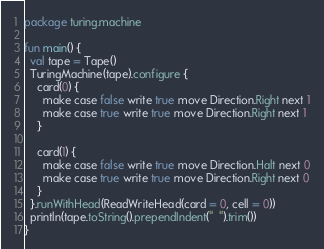<code> <loc_0><loc_0><loc_500><loc_500><_Kotlin_>package turing.machine

fun main() {
  val tape = Tape()
  TuringMachine(tape).configure {
    card(0) {
      make case false write true move Direction.Right next 1
      make case true write true move Direction.Right next 1
    }

    card(1) {
      make case false write true move Direction.Halt next 0
      make case true write true move Direction.Right next 0
    }
  }.runWithHead(ReadWriteHead(card = 0, cell = 0))
  println(tape.toString().prependIndent("  ").trim())
}
</code> 